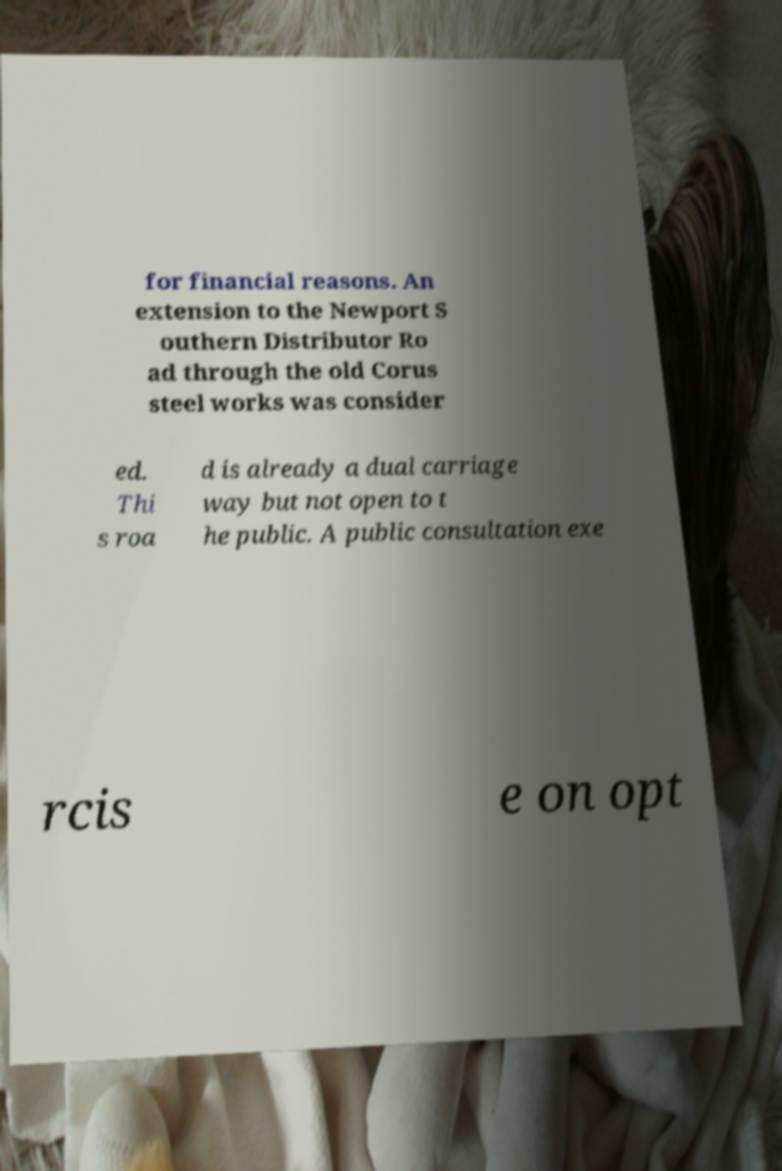Can you accurately transcribe the text from the provided image for me? for financial reasons. An extension to the Newport S outhern Distributor Ro ad through the old Corus steel works was consider ed. Thi s roa d is already a dual carriage way but not open to t he public. A public consultation exe rcis e on opt 